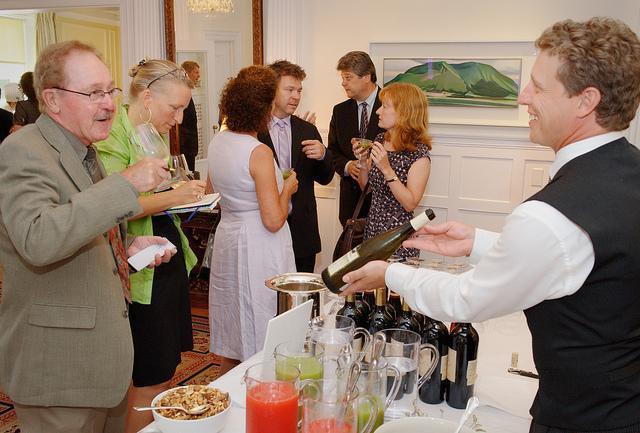How many people are serving?
Give a very brief answer. 1. How many people are in the picture?
Give a very brief answer. 7. How many bottles are there?
Give a very brief answer. 3. 